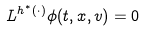<formula> <loc_0><loc_0><loc_500><loc_500>L ^ { h ^ { * } ( \cdot ) } \phi ( t , x , v ) = 0</formula> 